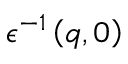<formula> <loc_0><loc_0><loc_500><loc_500>\epsilon ^ { - 1 } \left ( q , 0 \right )</formula> 